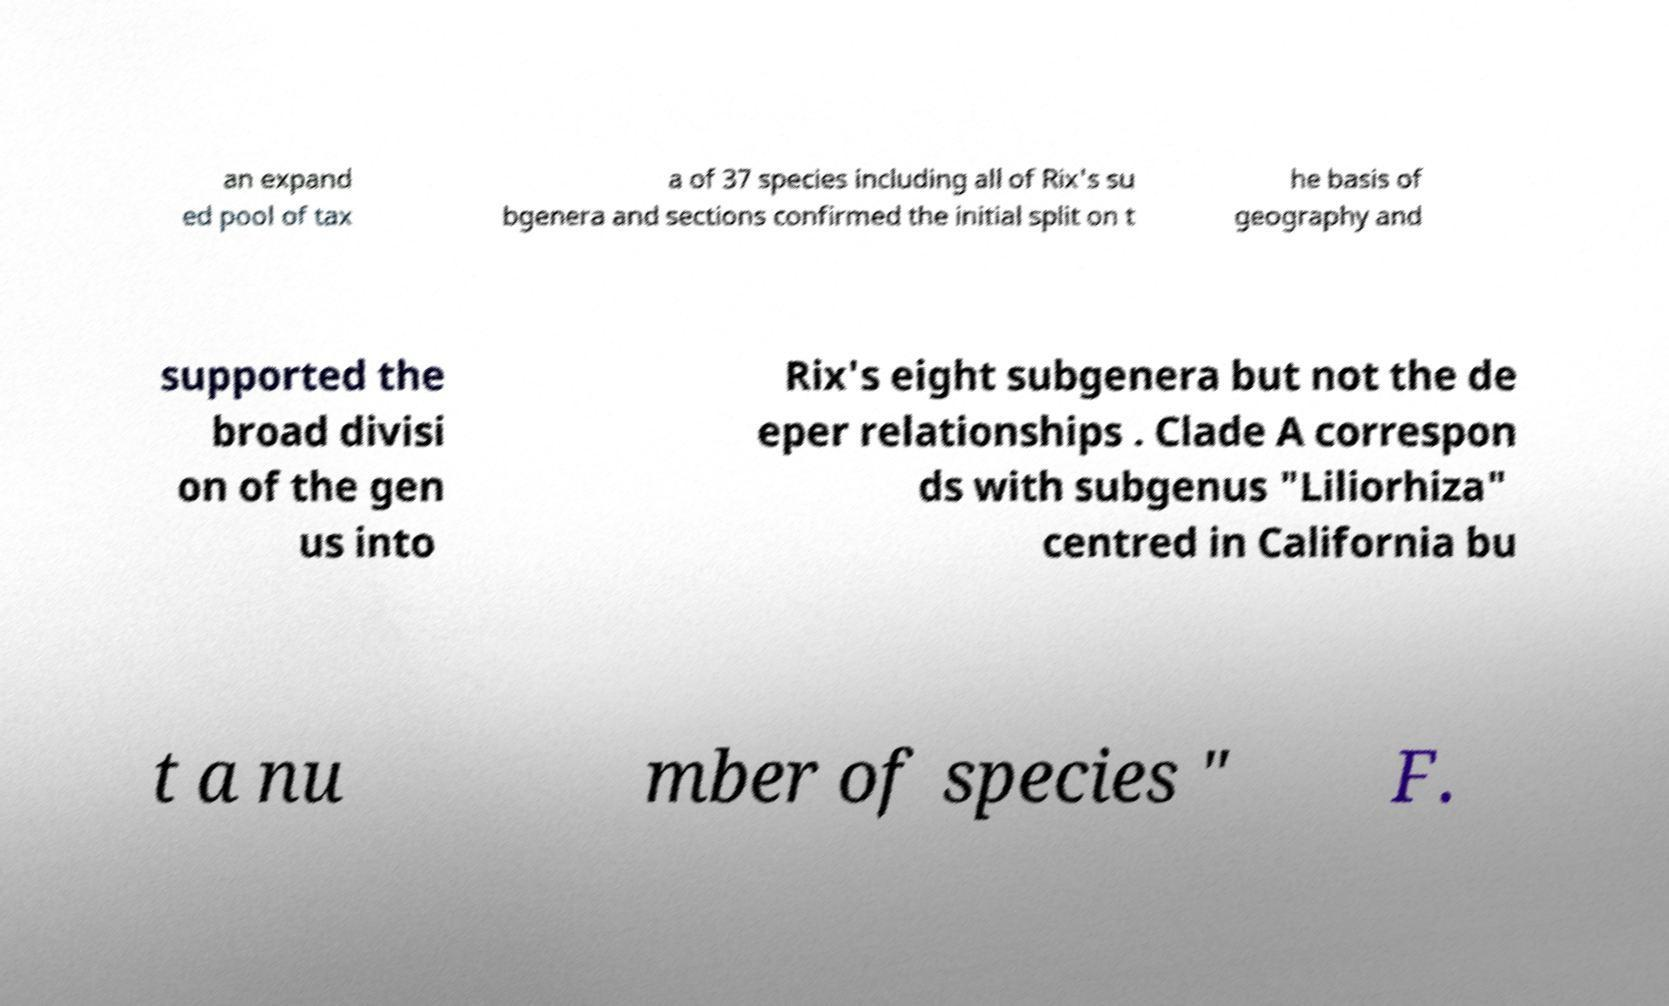There's text embedded in this image that I need extracted. Can you transcribe it verbatim? an expand ed pool of tax a of 37 species including all of Rix's su bgenera and sections confirmed the initial split on t he basis of geography and supported the broad divisi on of the gen us into Rix's eight subgenera but not the de eper relationships . Clade A correspon ds with subgenus "Liliorhiza" centred in California bu t a nu mber of species " F. 